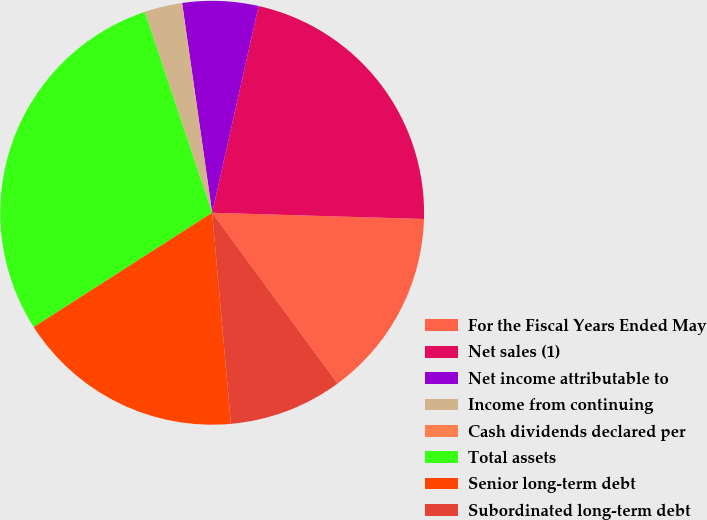Convert chart. <chart><loc_0><loc_0><loc_500><loc_500><pie_chart><fcel>For the Fiscal Years Ended May<fcel>Net sales (1)<fcel>Net income attributable to<fcel>Income from continuing<fcel>Cash dividends declared per<fcel>Total assets<fcel>Senior long-term debt<fcel>Subordinated long-term debt<nl><fcel>14.45%<fcel>21.95%<fcel>5.78%<fcel>2.89%<fcel>0.0%<fcel>28.91%<fcel>17.34%<fcel>8.67%<nl></chart> 